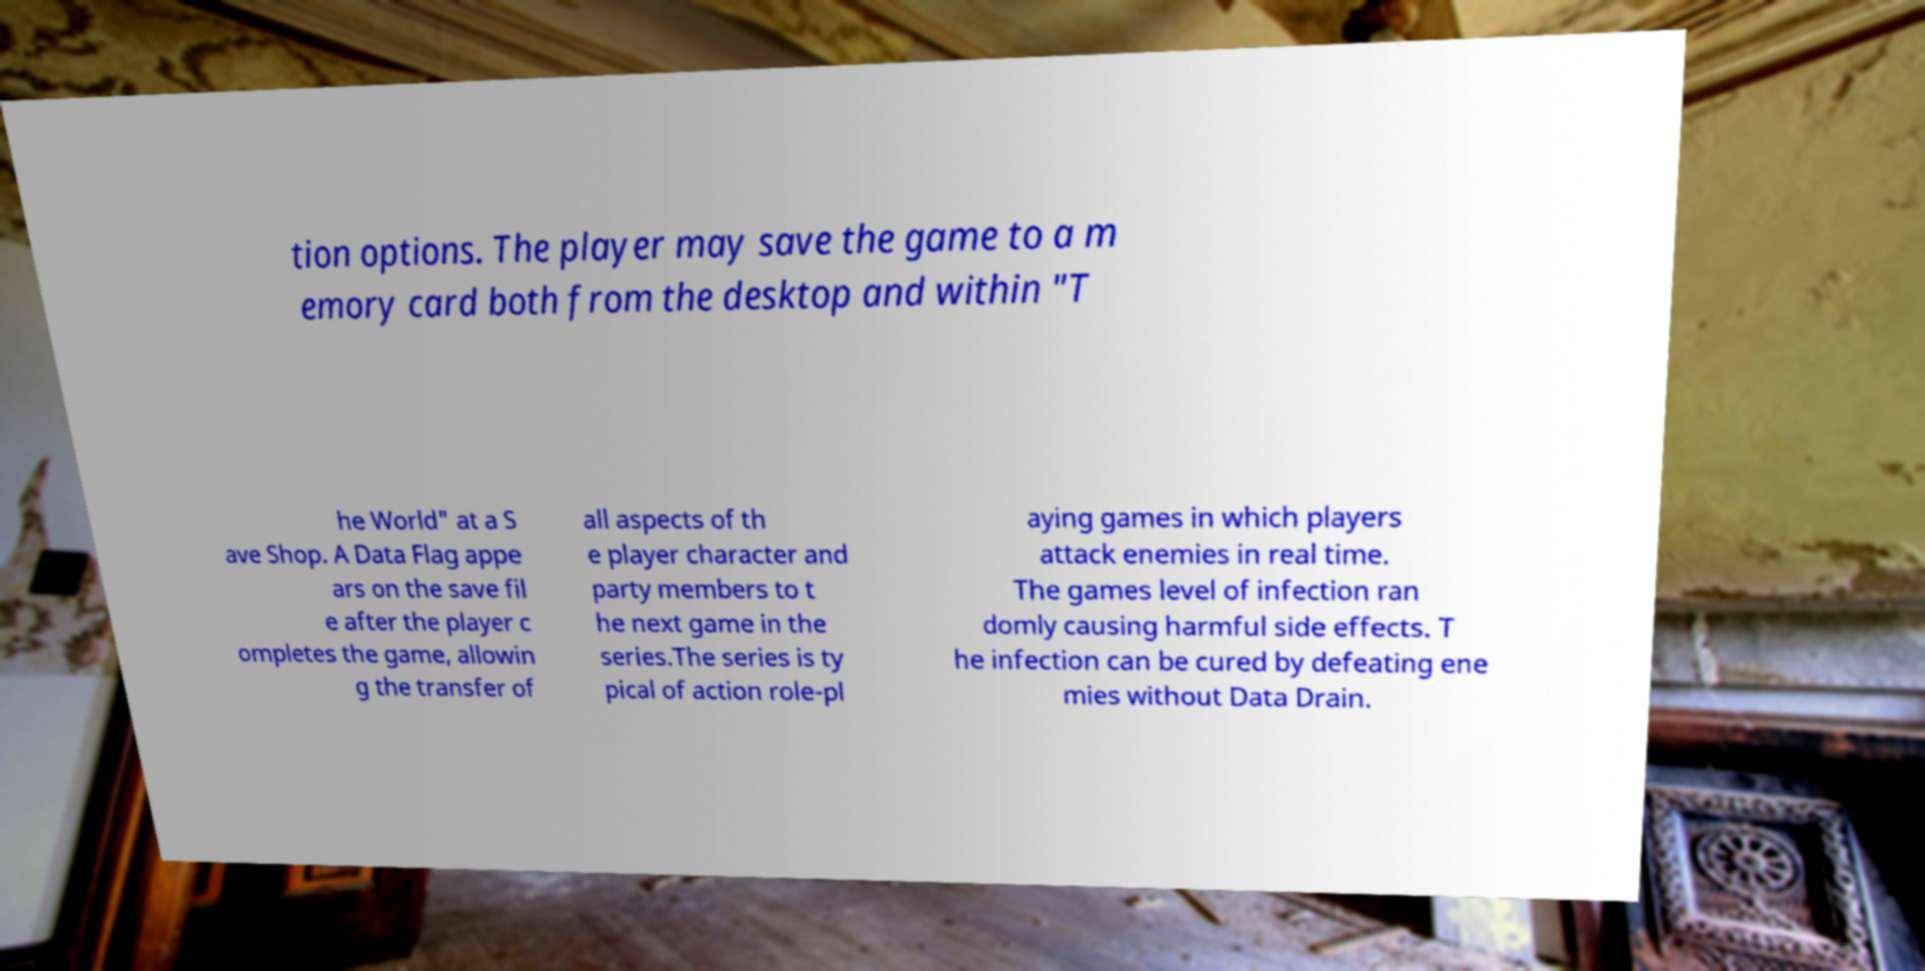There's text embedded in this image that I need extracted. Can you transcribe it verbatim? tion options. The player may save the game to a m emory card both from the desktop and within "T he World" at a S ave Shop. A Data Flag appe ars on the save fil e after the player c ompletes the game, allowin g the transfer of all aspects of th e player character and party members to t he next game in the series.The series is ty pical of action role-pl aying games in which players attack enemies in real time. The games level of infection ran domly causing harmful side effects. T he infection can be cured by defeating ene mies without Data Drain. 